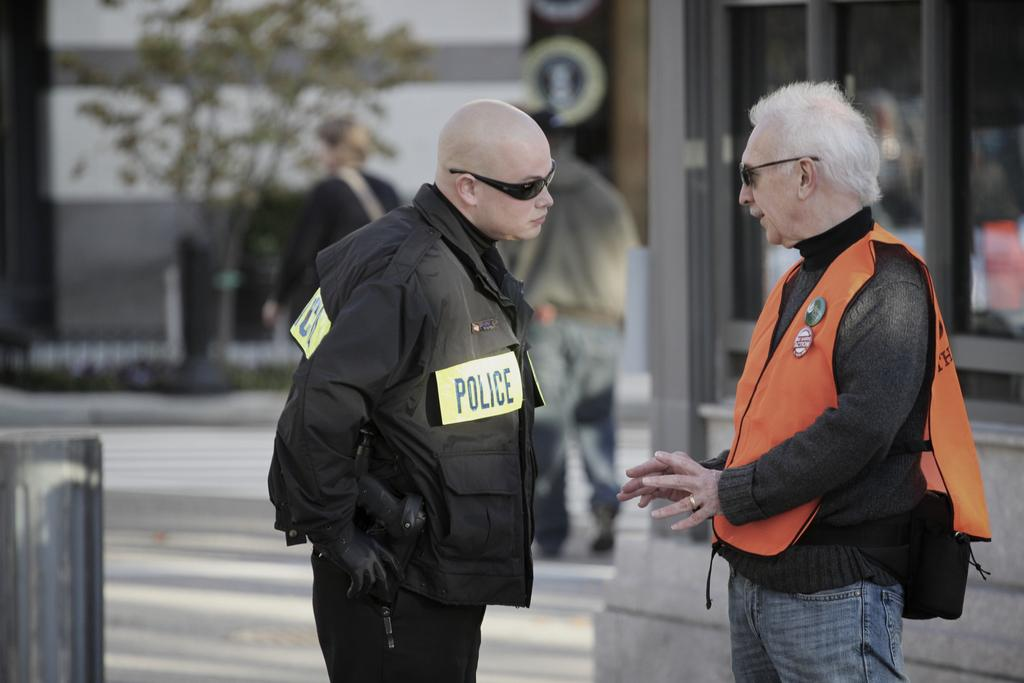How many people are in the front of the image? There are two people in the front of the image facing each other. What are the two people wearing? The two people are wearing jackets. Can you describe the background of the image? The background of the image is blurred, but there are people, boards, a tree, and a glass window visible. What type of approval does the woman in the image need to give? There is no woman present in the image, so it is not possible to determine what type of approval might be needed. 